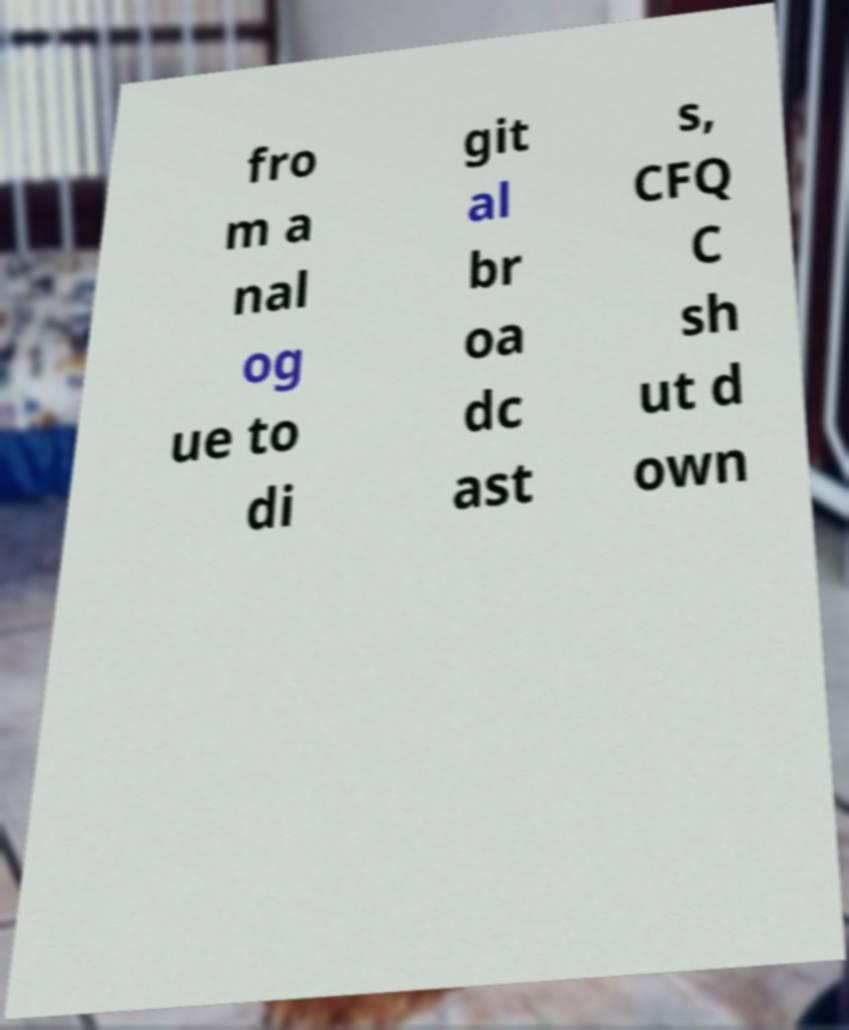I need the written content from this picture converted into text. Can you do that? fro m a nal og ue to di git al br oa dc ast s, CFQ C sh ut d own 